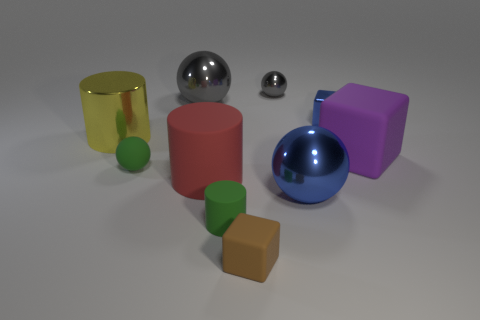Subtract all gray blocks. How many gray balls are left? 2 Subtract all red balls. Subtract all blue cubes. How many balls are left? 4 Subtract all blocks. How many objects are left? 7 Add 1 large rubber cylinders. How many large rubber cylinders are left? 2 Add 3 tiny green rubber objects. How many tiny green rubber objects exist? 5 Subtract 1 brown blocks. How many objects are left? 9 Subtract all yellow shiny things. Subtract all tiny gray rubber cylinders. How many objects are left? 9 